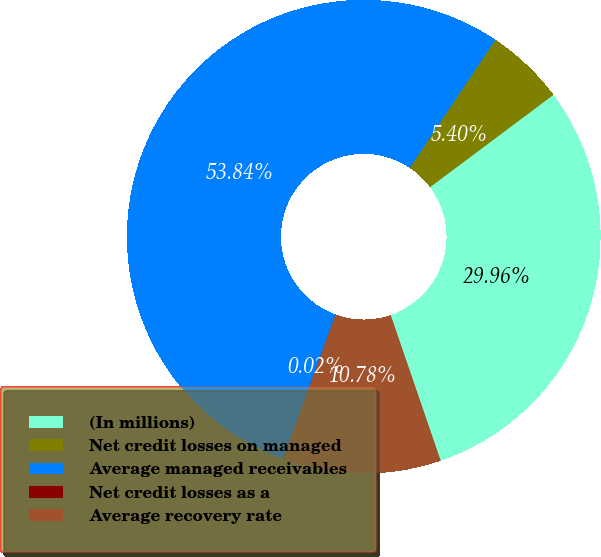<chart> <loc_0><loc_0><loc_500><loc_500><pie_chart><fcel>(In millions)<fcel>Net credit losses on managed<fcel>Average managed receivables<fcel>Net credit losses as a<fcel>Average recovery rate<nl><fcel>29.96%<fcel>5.4%<fcel>53.84%<fcel>0.02%<fcel>10.78%<nl></chart> 